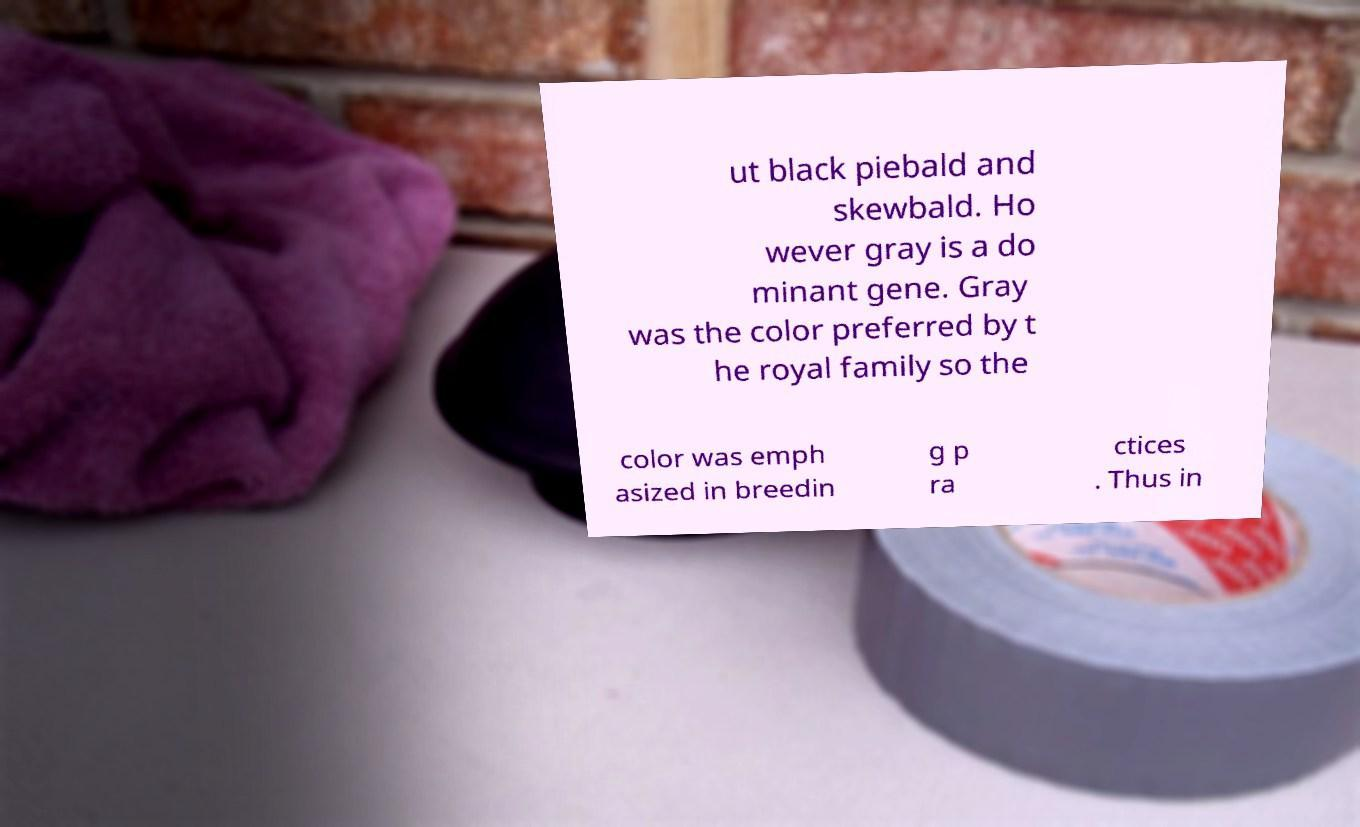I need the written content from this picture converted into text. Can you do that? ut black piebald and skewbald. Ho wever gray is a do minant gene. Gray was the color preferred by t he royal family so the color was emph asized in breedin g p ra ctices . Thus in 